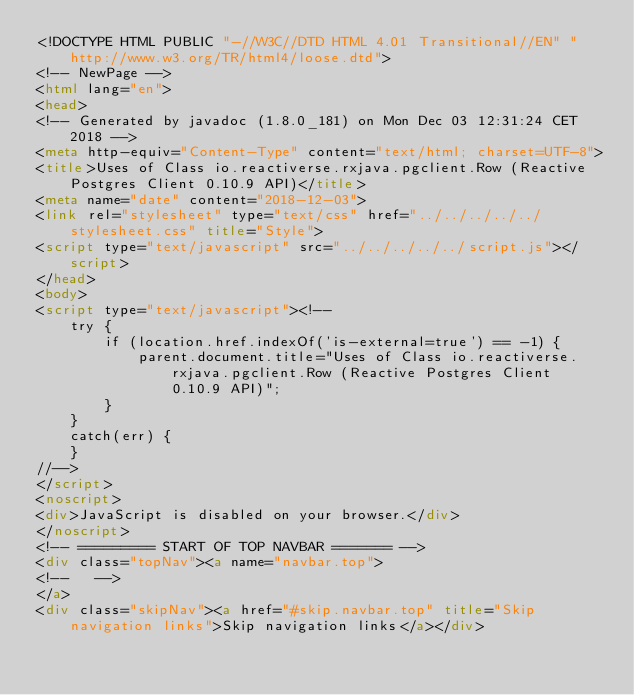<code> <loc_0><loc_0><loc_500><loc_500><_HTML_><!DOCTYPE HTML PUBLIC "-//W3C//DTD HTML 4.01 Transitional//EN" "http://www.w3.org/TR/html4/loose.dtd">
<!-- NewPage -->
<html lang="en">
<head>
<!-- Generated by javadoc (1.8.0_181) on Mon Dec 03 12:31:24 CET 2018 -->
<meta http-equiv="Content-Type" content="text/html; charset=UTF-8">
<title>Uses of Class io.reactiverse.rxjava.pgclient.Row (Reactive Postgres Client 0.10.9 API)</title>
<meta name="date" content="2018-12-03">
<link rel="stylesheet" type="text/css" href="../../../../../stylesheet.css" title="Style">
<script type="text/javascript" src="../../../../../script.js"></script>
</head>
<body>
<script type="text/javascript"><!--
    try {
        if (location.href.indexOf('is-external=true') == -1) {
            parent.document.title="Uses of Class io.reactiverse.rxjava.pgclient.Row (Reactive Postgres Client 0.10.9 API)";
        }
    }
    catch(err) {
    }
//-->
</script>
<noscript>
<div>JavaScript is disabled on your browser.</div>
</noscript>
<!-- ========= START OF TOP NAVBAR ======= -->
<div class="topNav"><a name="navbar.top">
<!--   -->
</a>
<div class="skipNav"><a href="#skip.navbar.top" title="Skip navigation links">Skip navigation links</a></div></code> 